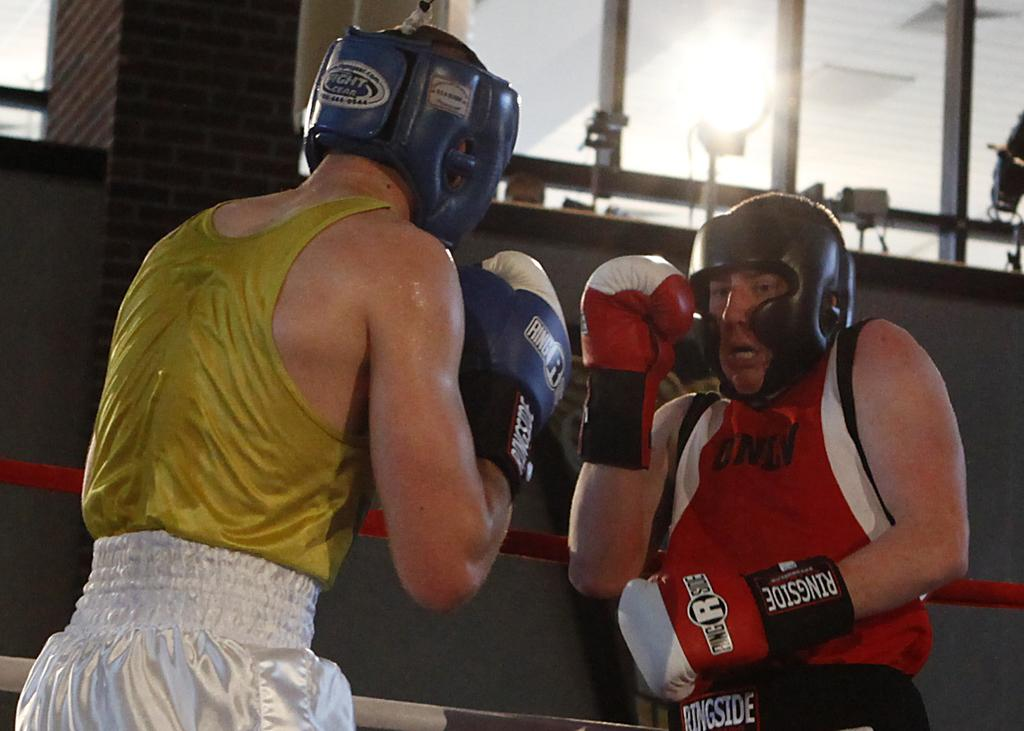<image>
Write a terse but informative summary of the picture. Two boxers wearing ringside brand kit fight in a boxing ring. 